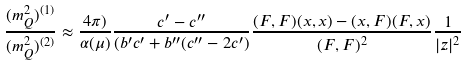Convert formula to latex. <formula><loc_0><loc_0><loc_500><loc_500>\frac { ( m ^ { 2 } _ { Q } ) ^ { ( 1 ) } } { ( m ^ { 2 } _ { Q } ) ^ { ( 2 ) } } \approx \frac { 4 \pi ) } { \alpha ( \mu ) } \frac { c ^ { \prime } - c ^ { \prime \prime } } { ( b ^ { \prime } c ^ { \prime } + b ^ { \prime \prime } ( c ^ { \prime \prime } - 2 c ^ { \prime } ) } \frac { ( F , F ) ( x , x ) - ( x , F ) ( F , x ) } { ( F , F ) ^ { 2 } } \frac { 1 } { | z | ^ { 2 } }</formula> 